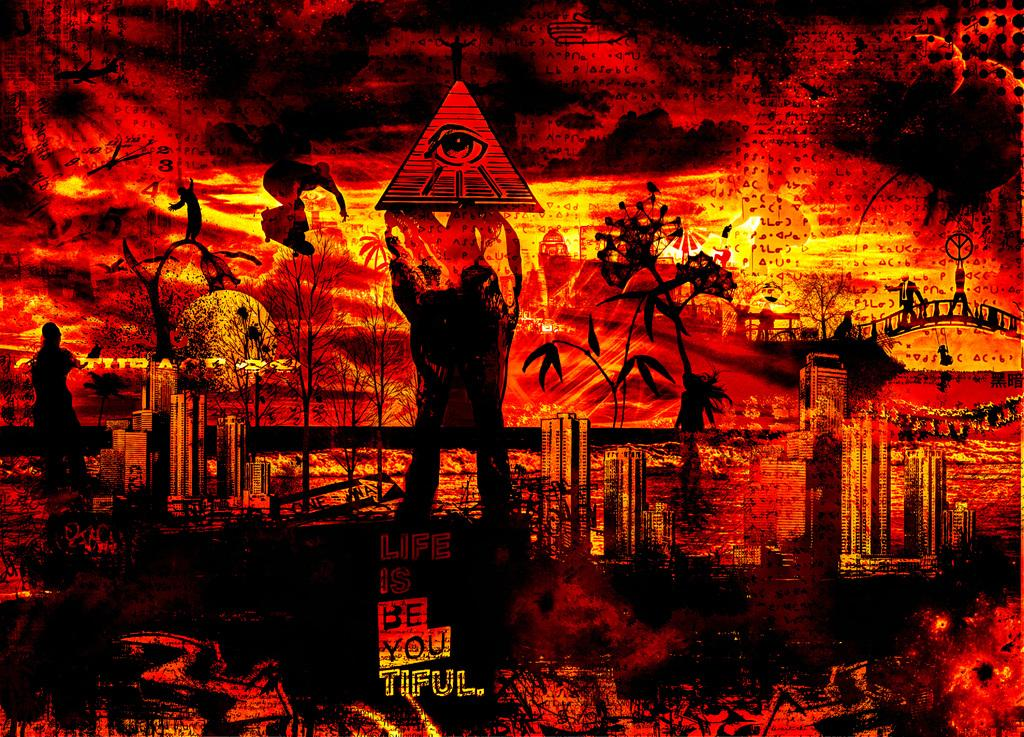<image>
Give a short and clear explanation of the subsequent image. An orange and black drawing with a man and pyramid with the saying life is beautiful. 